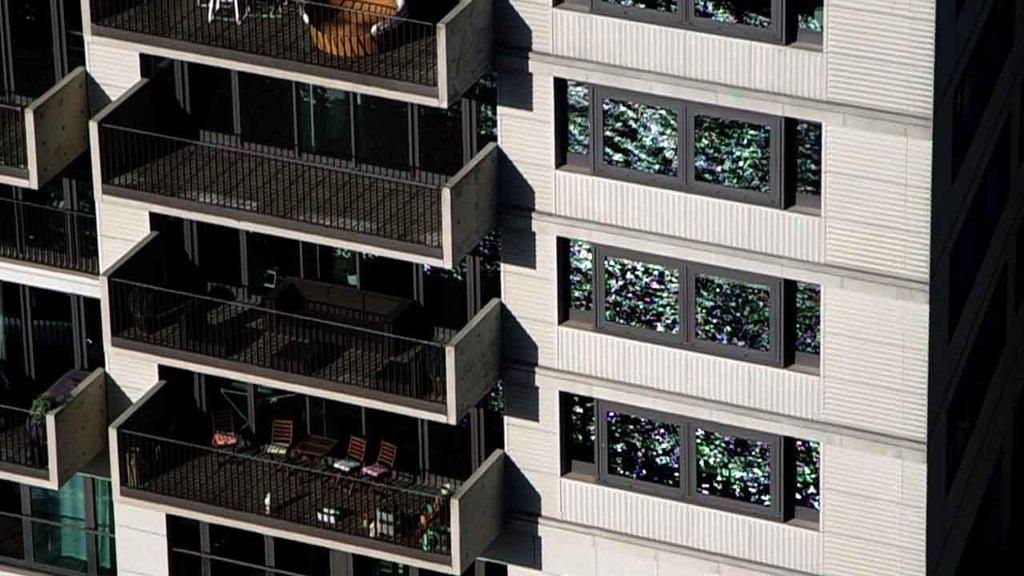What type of structure is visible in the image? There is a building in the image. What feature of the building is mentioned in the facts? The building has glass windows and doors. What can be seen on the balcony of the building? There are chairs and sofas in the balcony, as well as other objects. What safety feature is present on the balcony? The balcony has railings. What type of bread is being served on the balcony in the image? There is no bread present in the image; the facts mention chairs, sofas, and other objects on the balcony, but not bread. 